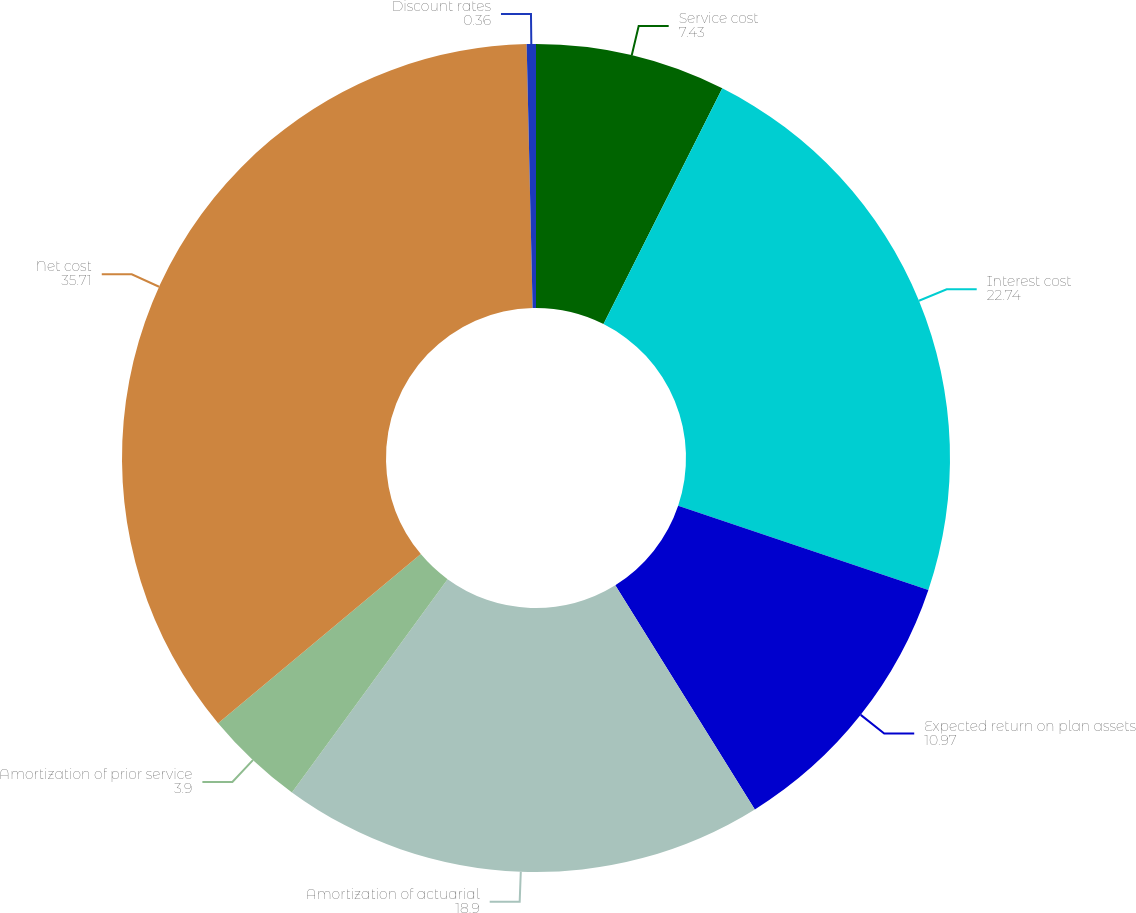Convert chart to OTSL. <chart><loc_0><loc_0><loc_500><loc_500><pie_chart><fcel>Service cost<fcel>Interest cost<fcel>Expected return on plan assets<fcel>Amortization of actuarial<fcel>Amortization of prior service<fcel>Net cost<fcel>Discount rates<nl><fcel>7.43%<fcel>22.74%<fcel>10.97%<fcel>18.9%<fcel>3.9%<fcel>35.71%<fcel>0.36%<nl></chart> 